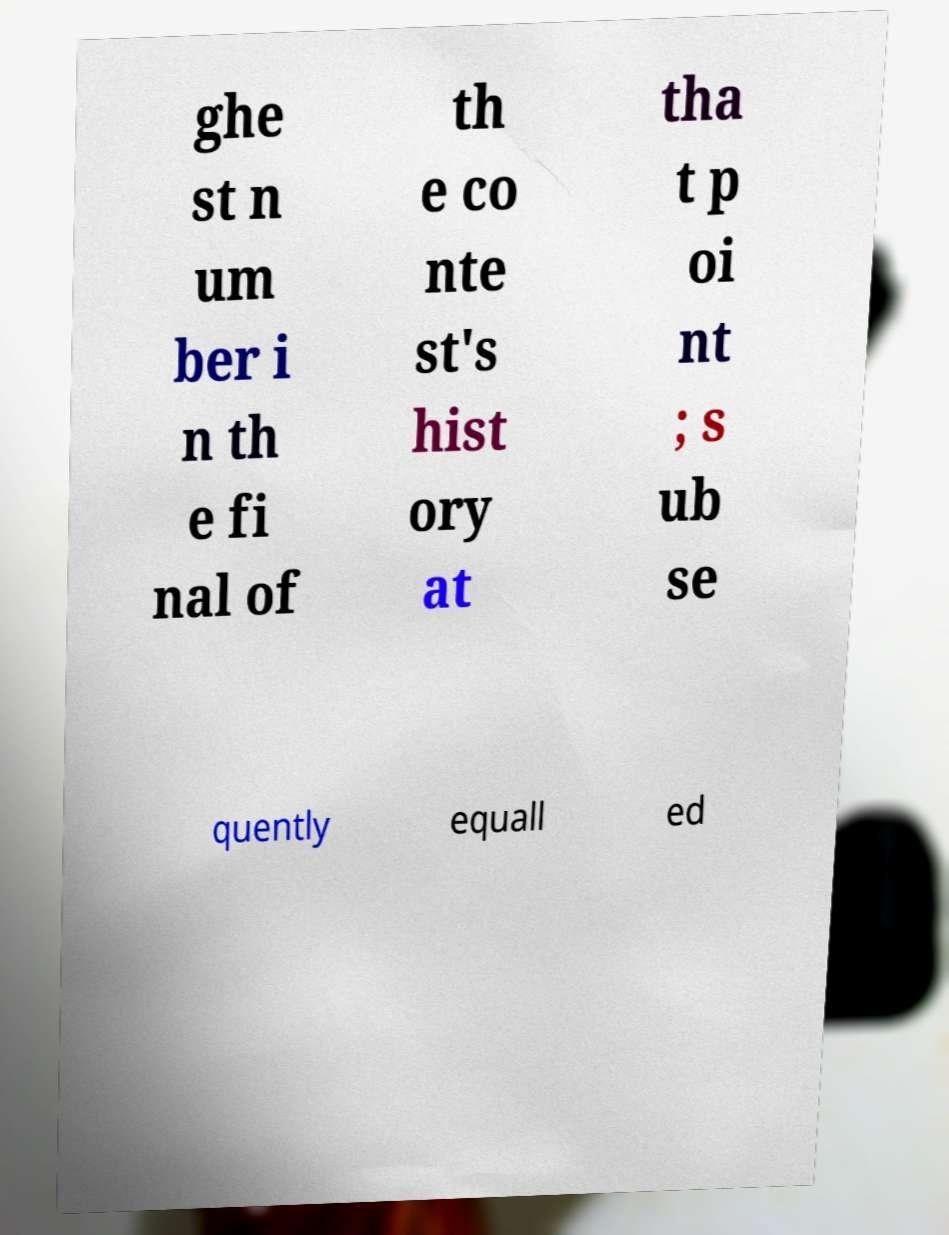Could you extract and type out the text from this image? ghe st n um ber i n th e fi nal of th e co nte st's hist ory at tha t p oi nt ; s ub se quently equall ed 